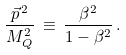Convert formula to latex. <formula><loc_0><loc_0><loc_500><loc_500>\frac { { \vec { p } } ^ { \, 2 } } { M _ { Q } ^ { 2 } } \, \equiv \, \frac { \beta ^ { 2 } } { 1 - \beta ^ { 2 } } \, .</formula> 